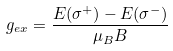<formula> <loc_0><loc_0><loc_500><loc_500>g _ { e x } = { \frac { E ( \sigma ^ { + } ) - E ( \sigma ^ { - } ) } { \mu _ { B } B } }</formula> 